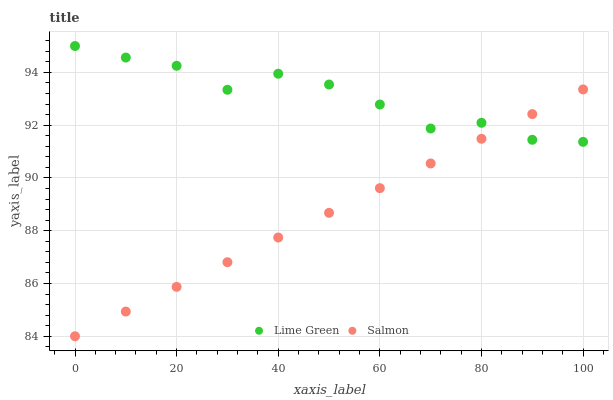Does Salmon have the minimum area under the curve?
Answer yes or no. Yes. Does Lime Green have the maximum area under the curve?
Answer yes or no. Yes. Does Lime Green have the minimum area under the curve?
Answer yes or no. No. Is Salmon the smoothest?
Answer yes or no. Yes. Is Lime Green the roughest?
Answer yes or no. Yes. Is Lime Green the smoothest?
Answer yes or no. No. Does Salmon have the lowest value?
Answer yes or no. Yes. Does Lime Green have the lowest value?
Answer yes or no. No. Does Lime Green have the highest value?
Answer yes or no. Yes. Does Lime Green intersect Salmon?
Answer yes or no. Yes. Is Lime Green less than Salmon?
Answer yes or no. No. Is Lime Green greater than Salmon?
Answer yes or no. No. 